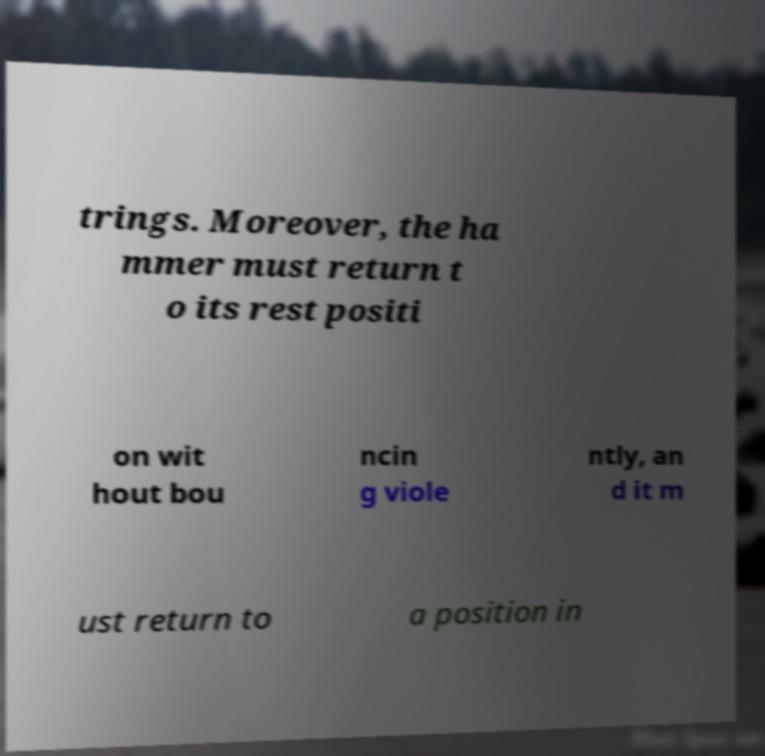Could you extract and type out the text from this image? trings. Moreover, the ha mmer must return t o its rest positi on wit hout bou ncin g viole ntly, an d it m ust return to a position in 